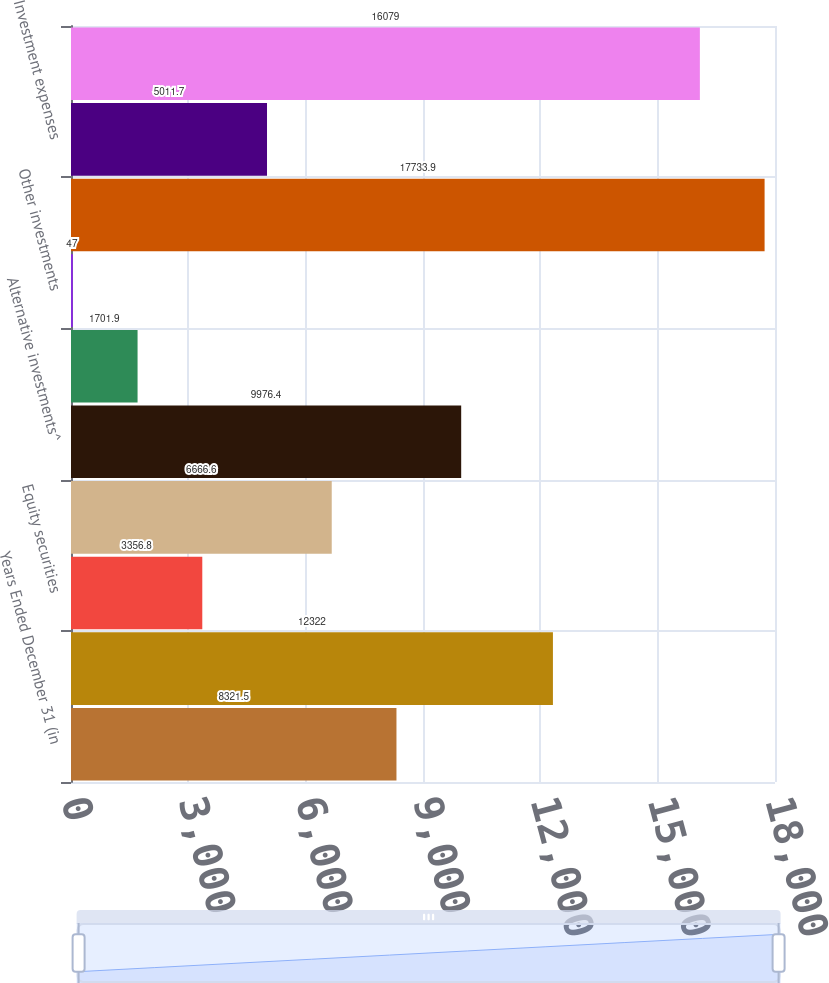Convert chart. <chart><loc_0><loc_0><loc_500><loc_500><bar_chart><fcel>Years Ended December 31 (in<fcel>Fixed maturity securities<fcel>Equity securities<fcel>Interest on mortgage and other<fcel>Alternative investments^<fcel>Real estate<fcel>Other investments<fcel>Total investment income<fcel>Investment expenses<fcel>Net investment income<nl><fcel>8321.5<fcel>12322<fcel>3356.8<fcel>6666.6<fcel>9976.4<fcel>1701.9<fcel>47<fcel>17733.9<fcel>5011.7<fcel>16079<nl></chart> 